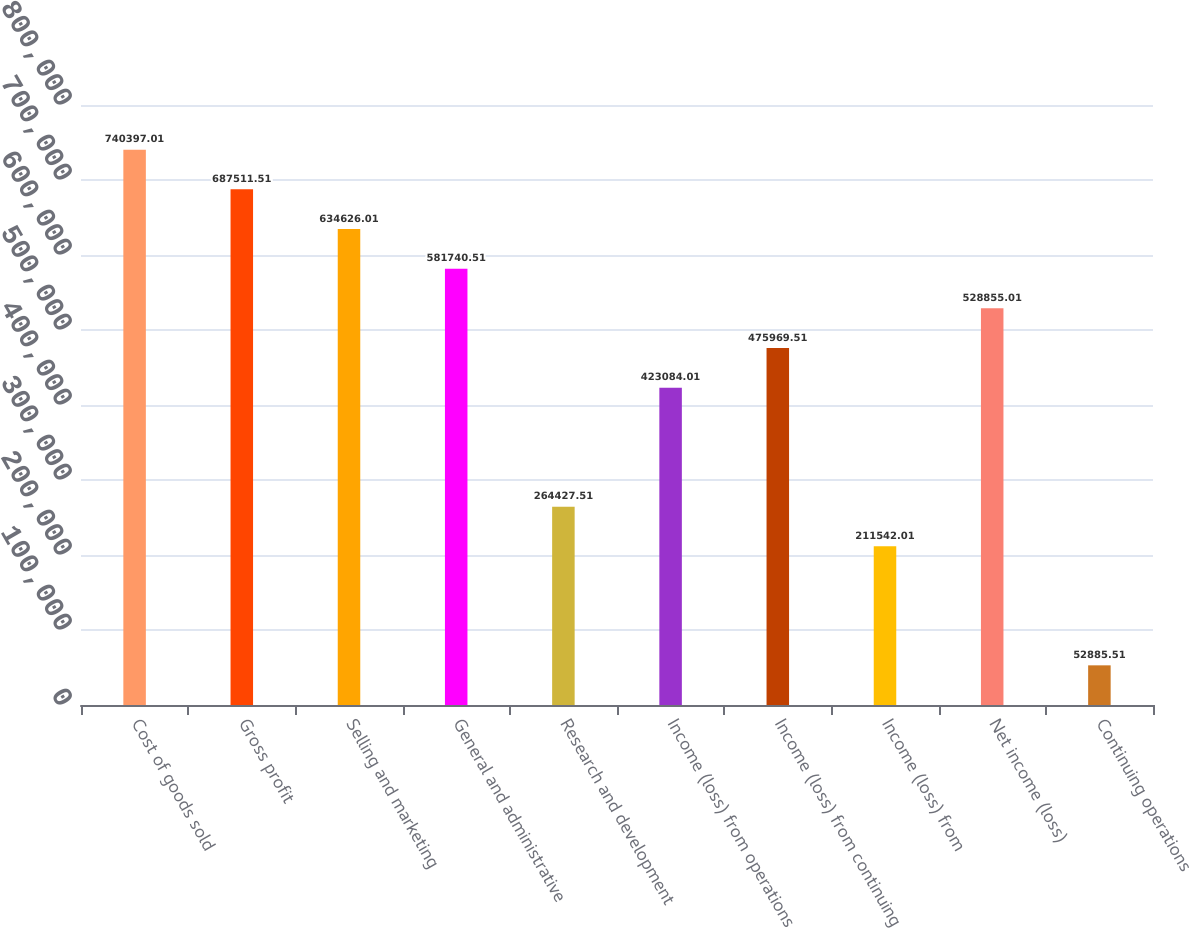Convert chart to OTSL. <chart><loc_0><loc_0><loc_500><loc_500><bar_chart><fcel>Cost of goods sold<fcel>Gross profit<fcel>Selling and marketing<fcel>General and administrative<fcel>Research and development<fcel>Income (loss) from operations<fcel>Income (loss) from continuing<fcel>Income (loss) from<fcel>Net income (loss)<fcel>Continuing operations<nl><fcel>740397<fcel>687512<fcel>634626<fcel>581741<fcel>264428<fcel>423084<fcel>475970<fcel>211542<fcel>528855<fcel>52885.5<nl></chart> 